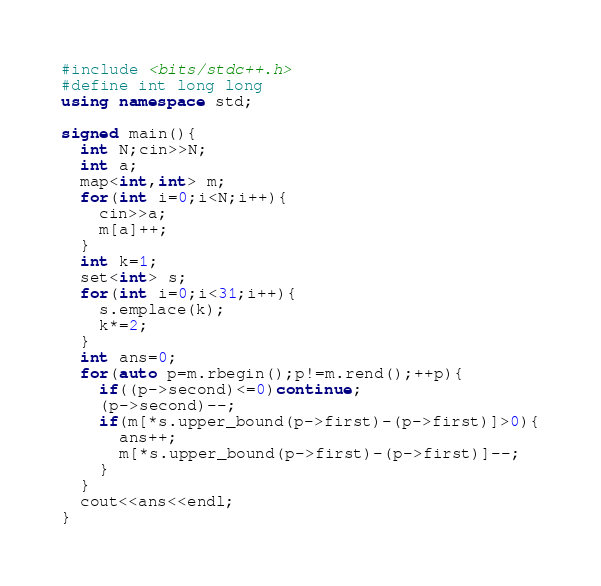Convert code to text. <code><loc_0><loc_0><loc_500><loc_500><_C++_>#include <bits/stdc++.h>
#define int long long
using namespace std;

signed main(){
  int N;cin>>N;
  int a;
  map<int,int> m;
  for(int i=0;i<N;i++){
    cin>>a;
    m[a]++;
  }
  int k=1;
  set<int> s;
  for(int i=0;i<31;i++){
    s.emplace(k);
    k*=2;
  }
  int ans=0;
  for(auto p=m.rbegin();p!=m.rend();++p){
    if((p->second)<=0)continue;
    (p->second)--;
    if(m[*s.upper_bound(p->first)-(p->first)]>0){
      ans++;
      m[*s.upper_bound(p->first)-(p->first)]--;
    }
  }
  cout<<ans<<endl;
}
</code> 